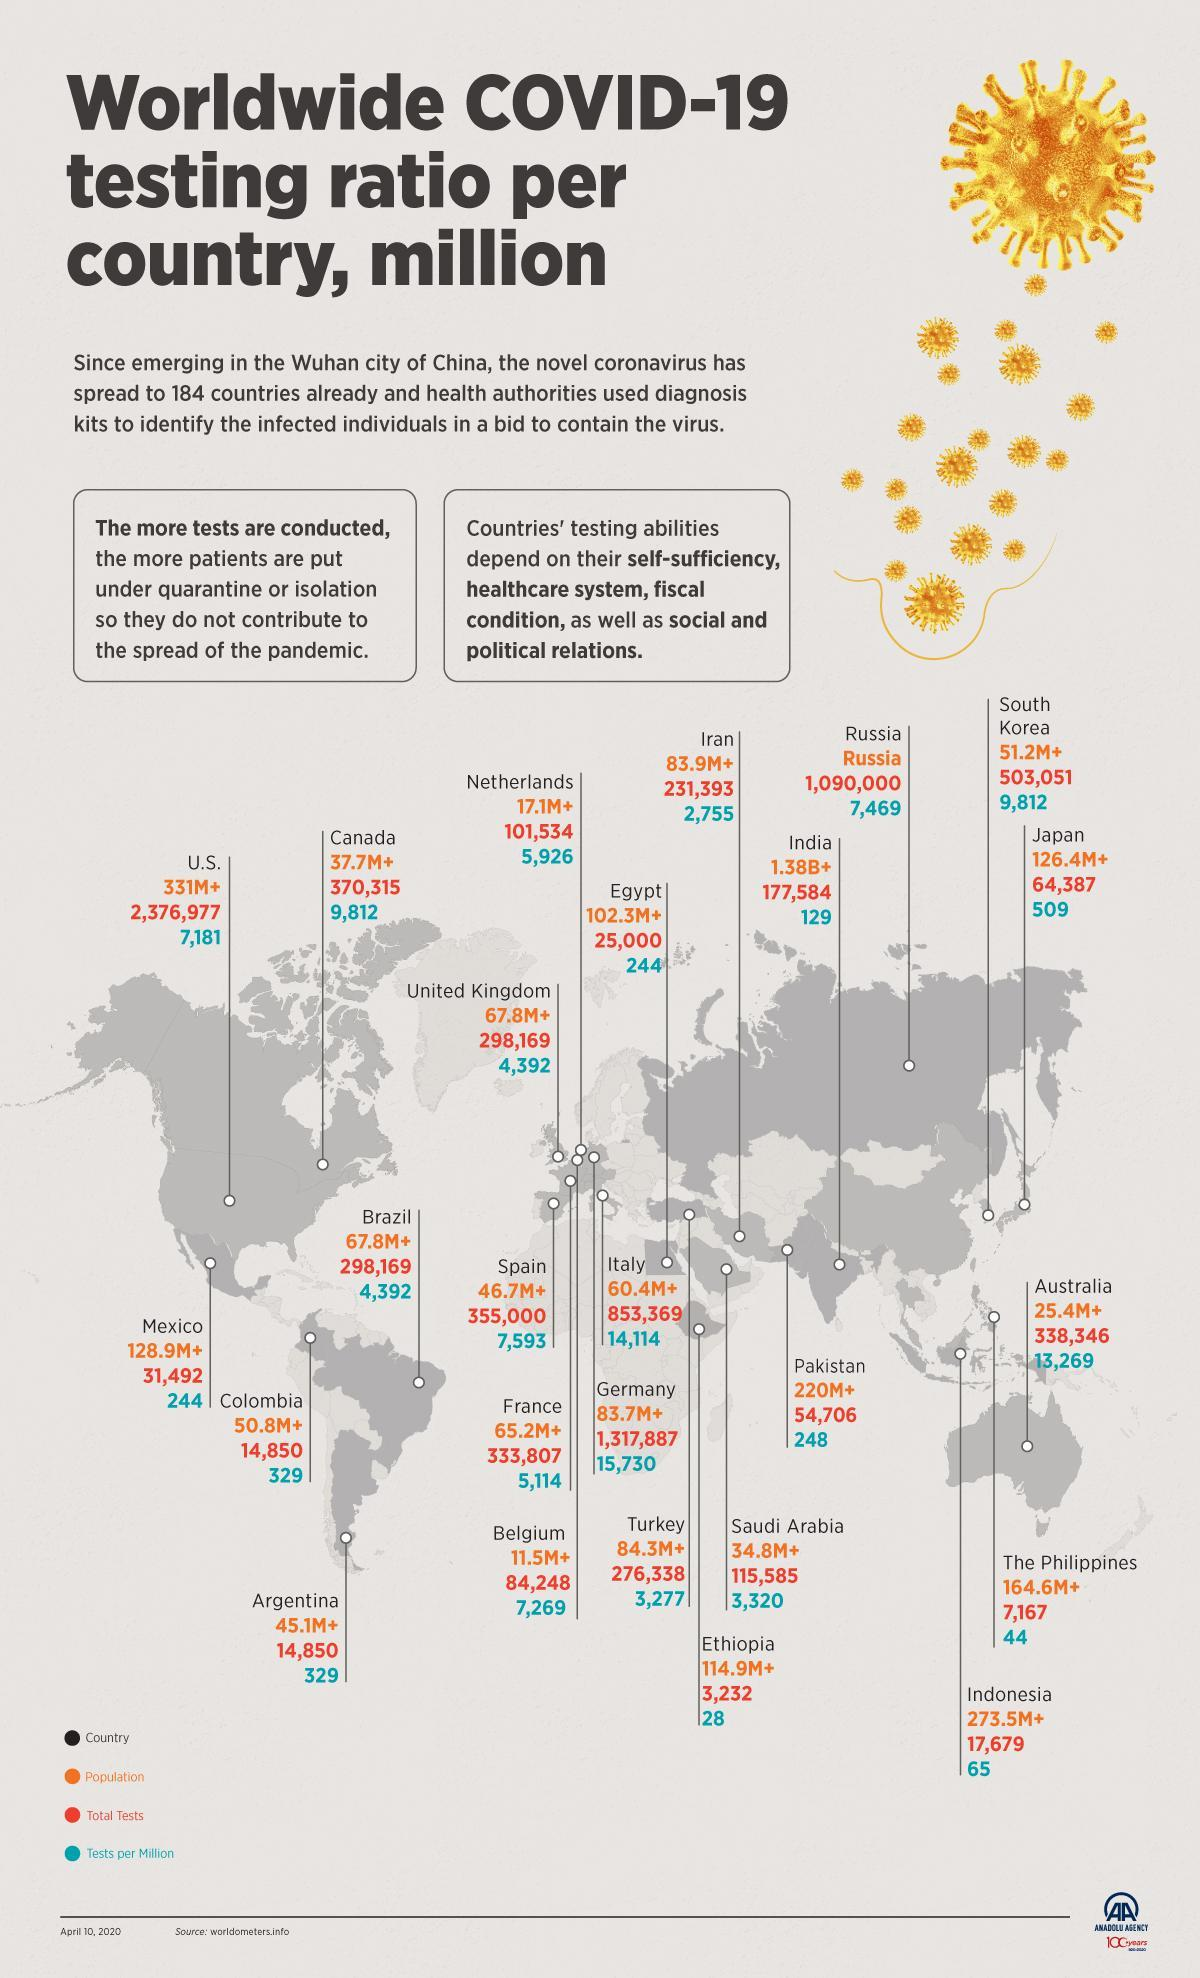What is the population of Mexico as of April 10, 2020?
Answer the question with a short phrase. 128.9M+ What is the total number of COVID-19 tests conducted in Japan as of April 10, 2020? 64,387 What is the total number of COVID-19 tests conducted in Spain as of April 10, 2020? 355,000 How many COVID-19 tests per million population were conducted in the U.S. as of April 10, 2020? 7,181 What is the population of Argentina as of April 10, 2020? 45.1M+ What is the total number of COVID-19 tests conducted in Italy as of April 10, 2020? 853,369 How many COVID-19 tests per million population were conducted in India as of April 10, 2020? 129 What is the population of India as of April 10, 2020? 1.38B+ What is the population of UK as of April 10, 2020? 67.8M+ How many COVID-19 tests per million population were conducted in the Germany as of April 10, 2020? 15,730 